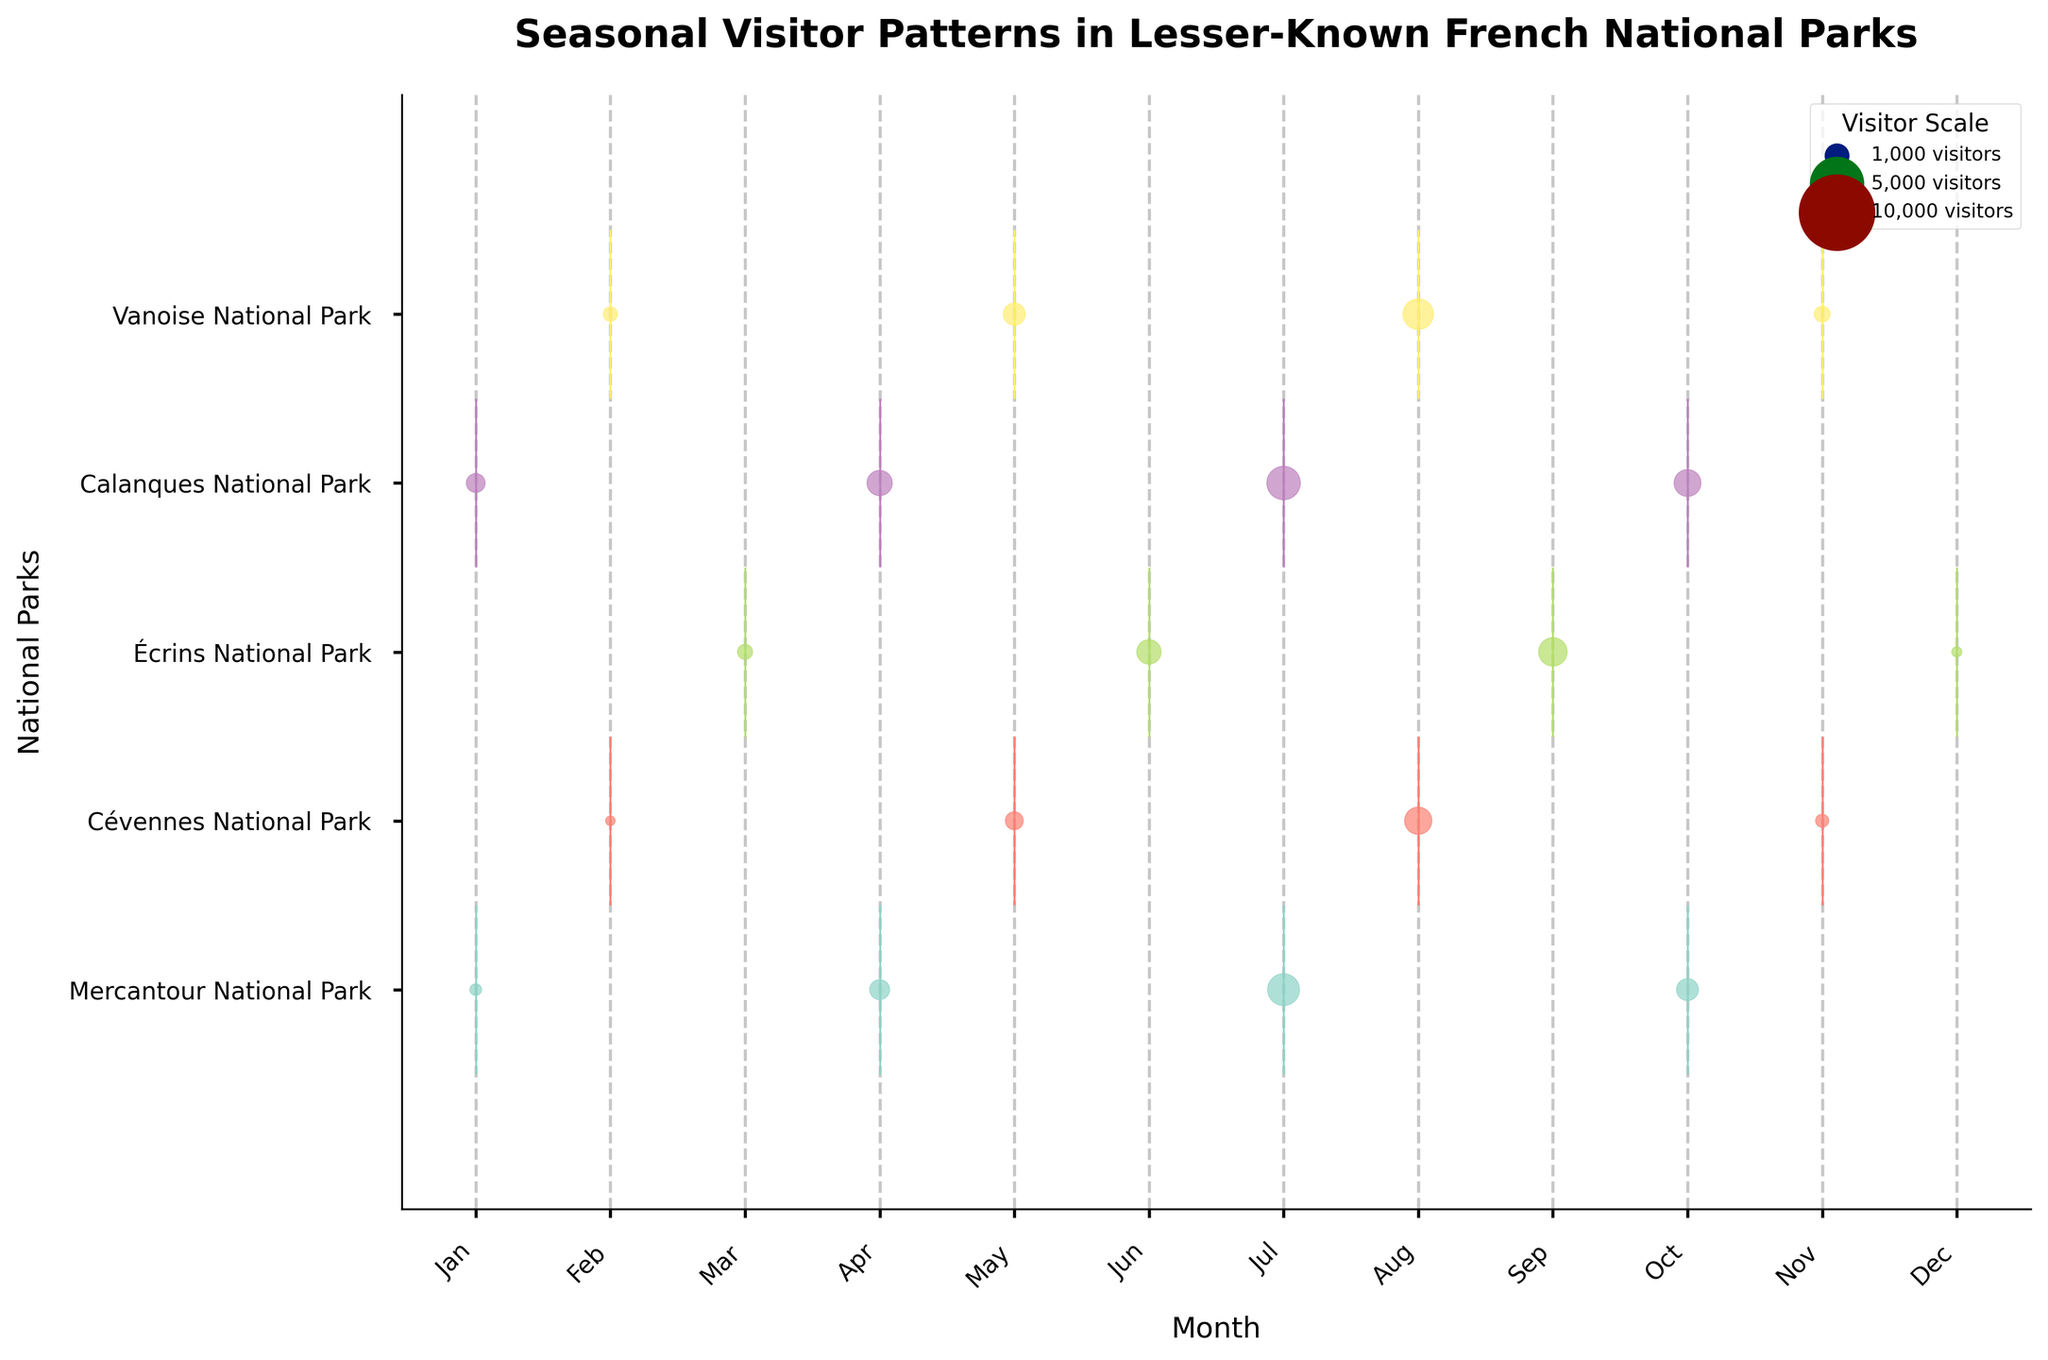What is the title of the figure? The title of the figure is usually displayed prominently at the top. In this case, it is written in bold and larger font size.
Answer: "Seasonal Visitor Patterns in Lesser-Known French National Parks" Which national park has the highest number of visitors in July? To find the park with the highest number of visitors in July, look for the park with the largest circle at the month labeled "Jul".
Answer: Calanques National Park During which month does Vanoise National Park see peak visitor numbers? To determine the peak visitor month for Vanoise National Park, identify the month with the largest circle in the row corresponding to Vanoise National Park.
Answer: August Which park experiences the least visitor fluctuation across the year? Compare the circles representing visitor numbers throughout all months for each park. The park with the most similarly sized circles experiences the least fluctuation.
Answer: Écrins National Park How do the visitor patterns compare between Mercantour National Park and Cévennes National Park in April? Compare the circles for both parks in April. The circle sizes represent visitor numbers, and the position on the x-axis corresponds to the month.
Answer: Mercantour has more visitors in April What is the general trend for visitor numbers in Calanques National Park through the seasons? Follow the positions and sizes of the circles across all months for Calanques National Park. Assess the pattern to determine if visitors increase, decrease, or stay constant through the seasons.
Answer: Increasing in summer, peaking in July-October Which month sees the lowest visitor numbers overall across all the parks? Look for the smallest aggregate circle sizes across all the parks for each month and find the month where the circles are generally the smallest.
Answer: February Are there any parks that have a concentrated visitor season? If so, which ones? Look for parks that have one or two exceedingly large circles compared to other months, indicating a concentrated visitor season.
Answer: Cévennes National Park (August), Vanoise National Park (August) On average, which season attracts the most visitors across all parks? Consider the data for the months corresponding to each season and compare the average size of the circles for those months.  Sum the visitor numbers for each season and find the season with the highest total.
Answer: Summer 